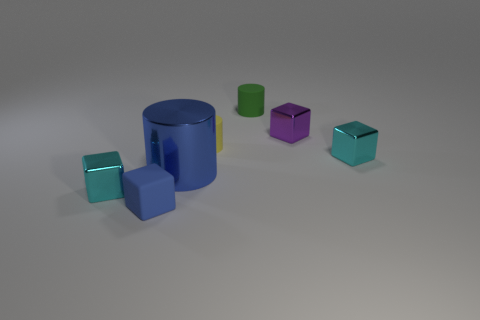Can you tell me more about the lighting and shadows cast by the objects? The objects in the image appear to be illuminated by a light source from the top left, given the direction of the shadows. Each object casts a soft-edged shadow diagonally to the bottom right, suggesting a singular distant light source creating a diffuse shadow effect. 